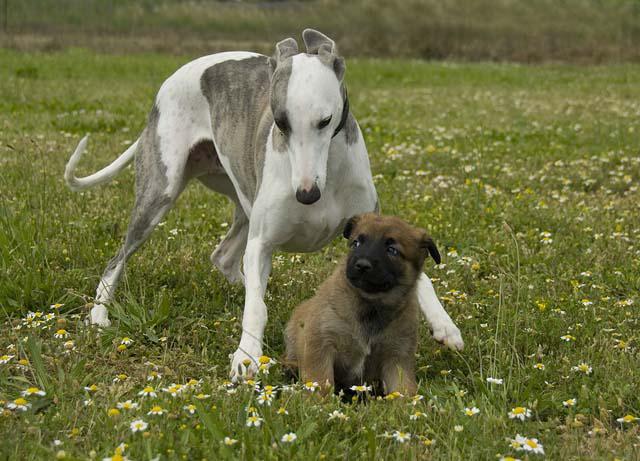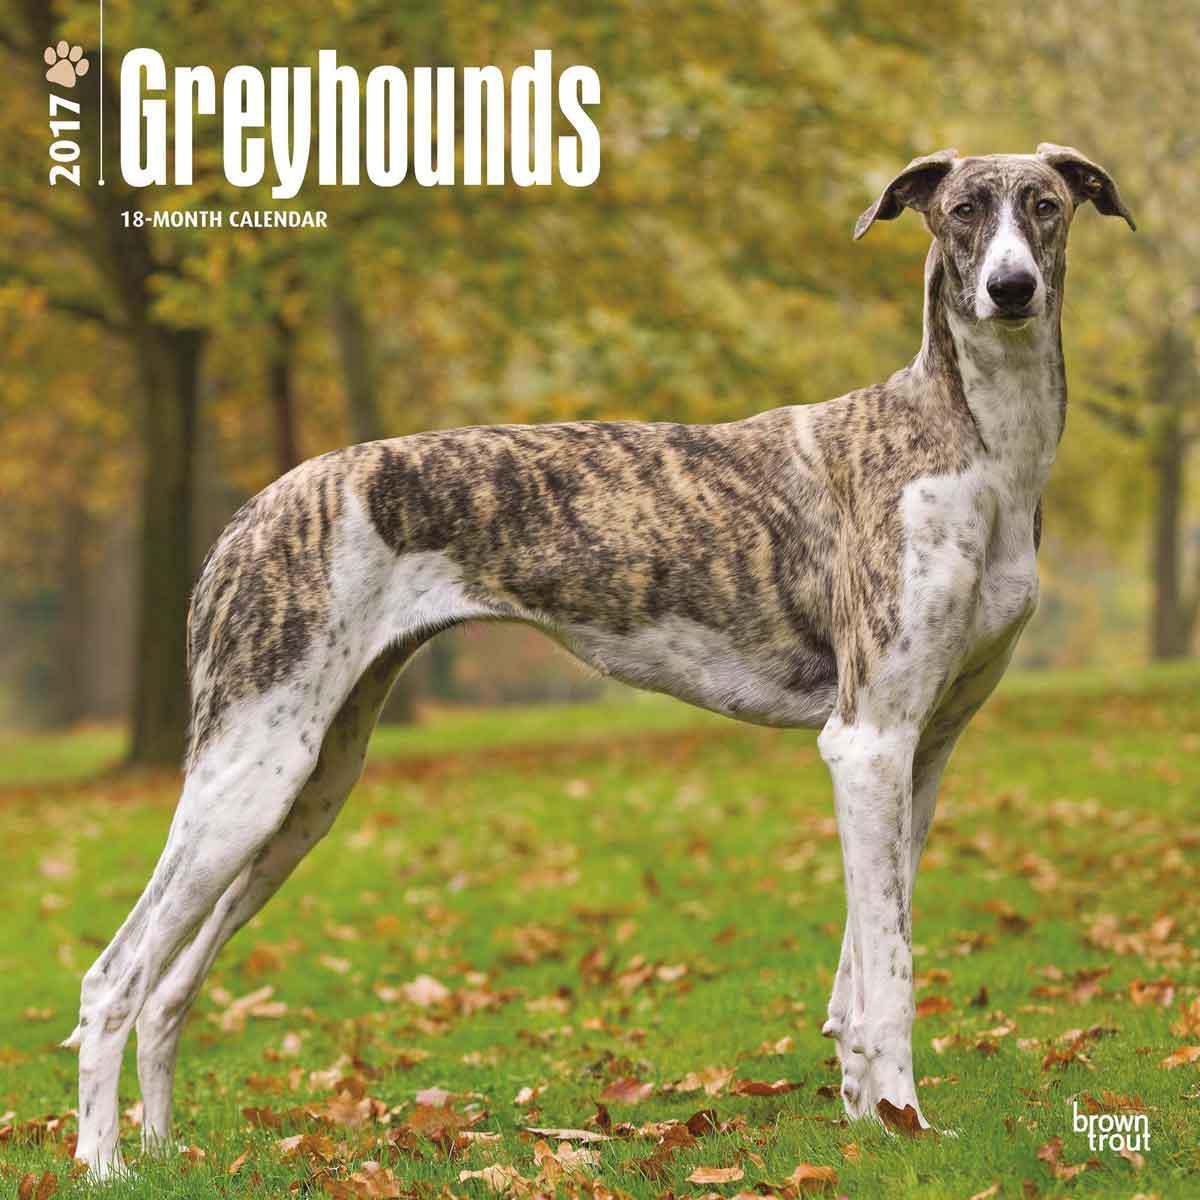The first image is the image on the left, the second image is the image on the right. For the images displayed, is the sentence "An image shows a single dog bounding across a field, with its head partially forward." factually correct? Answer yes or no. No. The first image is the image on the left, the second image is the image on the right. Assess this claim about the two images: "An image contains exactly two dogs.". Correct or not? Answer yes or no. Yes. 